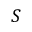<formula> <loc_0><loc_0><loc_500><loc_500>S</formula> 